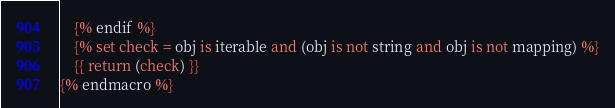Convert code to text. <code><loc_0><loc_0><loc_500><loc_500><_SQL_>    {% endif %}
    {% set check = obj is iterable and (obj is not string and obj is not mapping) %}
    {{ return (check) }}
{% endmacro %}</code> 